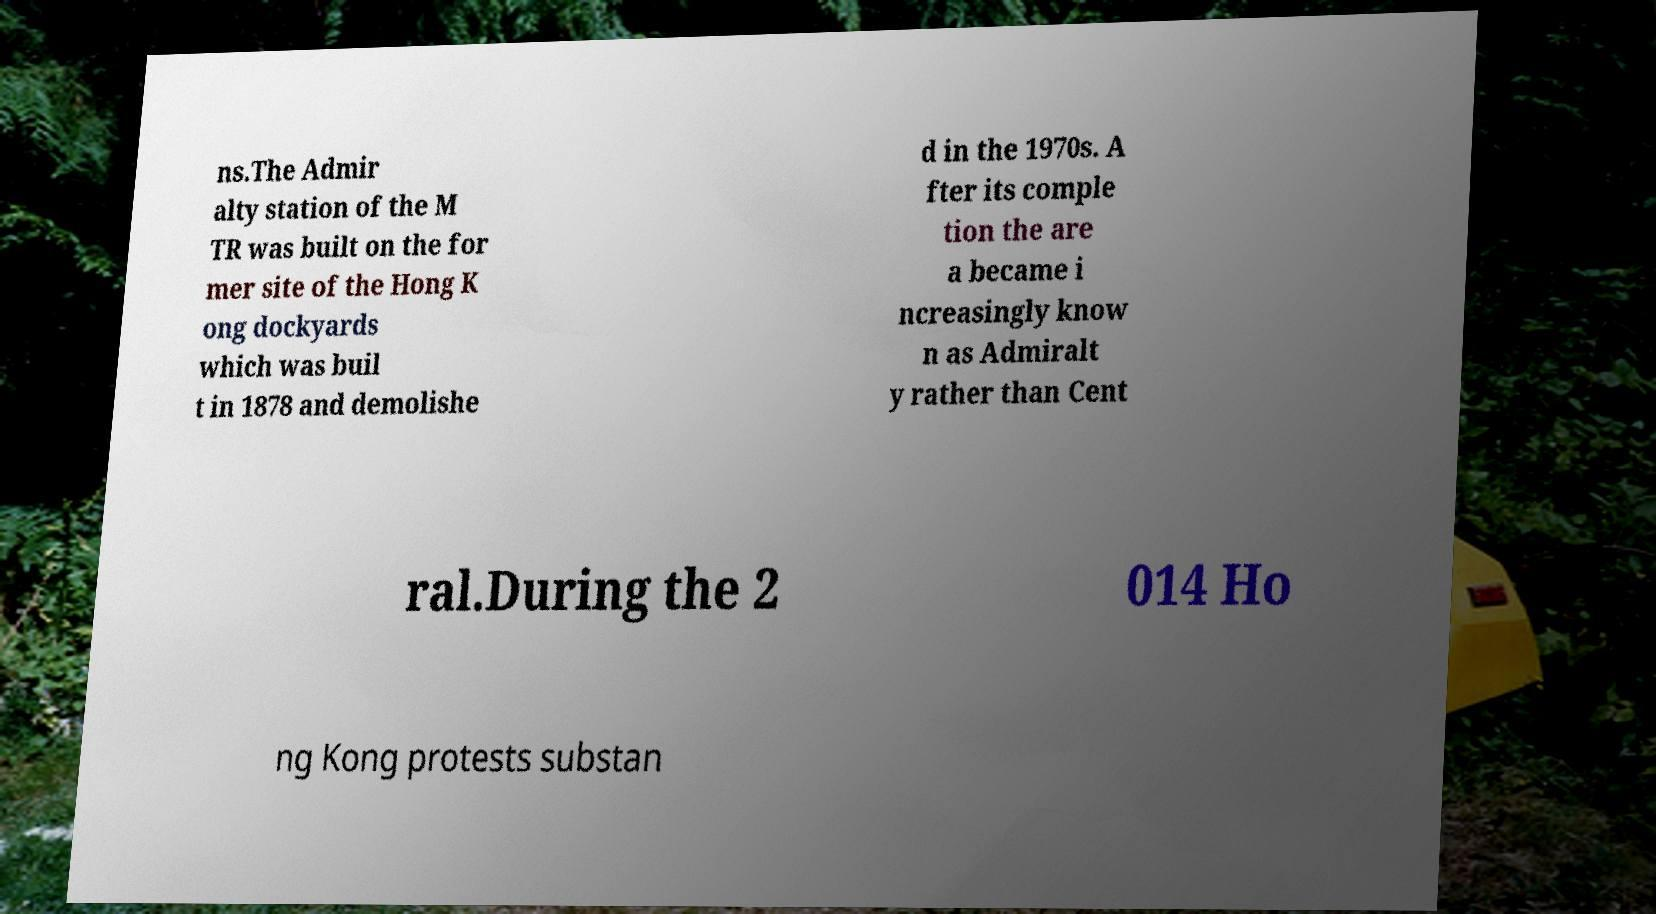Please identify and transcribe the text found in this image. ns.The Admir alty station of the M TR was built on the for mer site of the Hong K ong dockyards which was buil t in 1878 and demolishe d in the 1970s. A fter its comple tion the are a became i ncreasingly know n as Admiralt y rather than Cent ral.During the 2 014 Ho ng Kong protests substan 